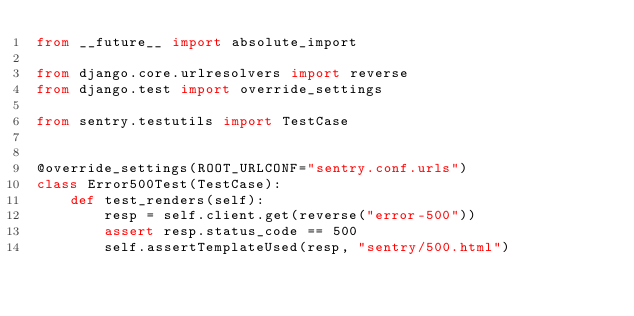<code> <loc_0><loc_0><loc_500><loc_500><_Python_>from __future__ import absolute_import

from django.core.urlresolvers import reverse
from django.test import override_settings

from sentry.testutils import TestCase


@override_settings(ROOT_URLCONF="sentry.conf.urls")
class Error500Test(TestCase):
    def test_renders(self):
        resp = self.client.get(reverse("error-500"))
        assert resp.status_code == 500
        self.assertTemplateUsed(resp, "sentry/500.html")
</code> 